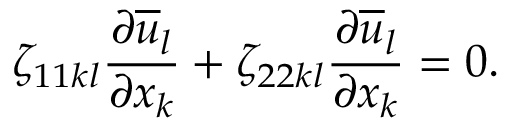Convert formula to latex. <formula><loc_0><loc_0><loc_500><loc_500>\zeta _ { 1 1 k l } \frac { \partial \overline { u } _ { l } } { \partial x _ { k } } + \zeta _ { 2 2 k l } \frac { \partial \overline { u } _ { l } } { \partial x _ { k } } = 0 .</formula> 